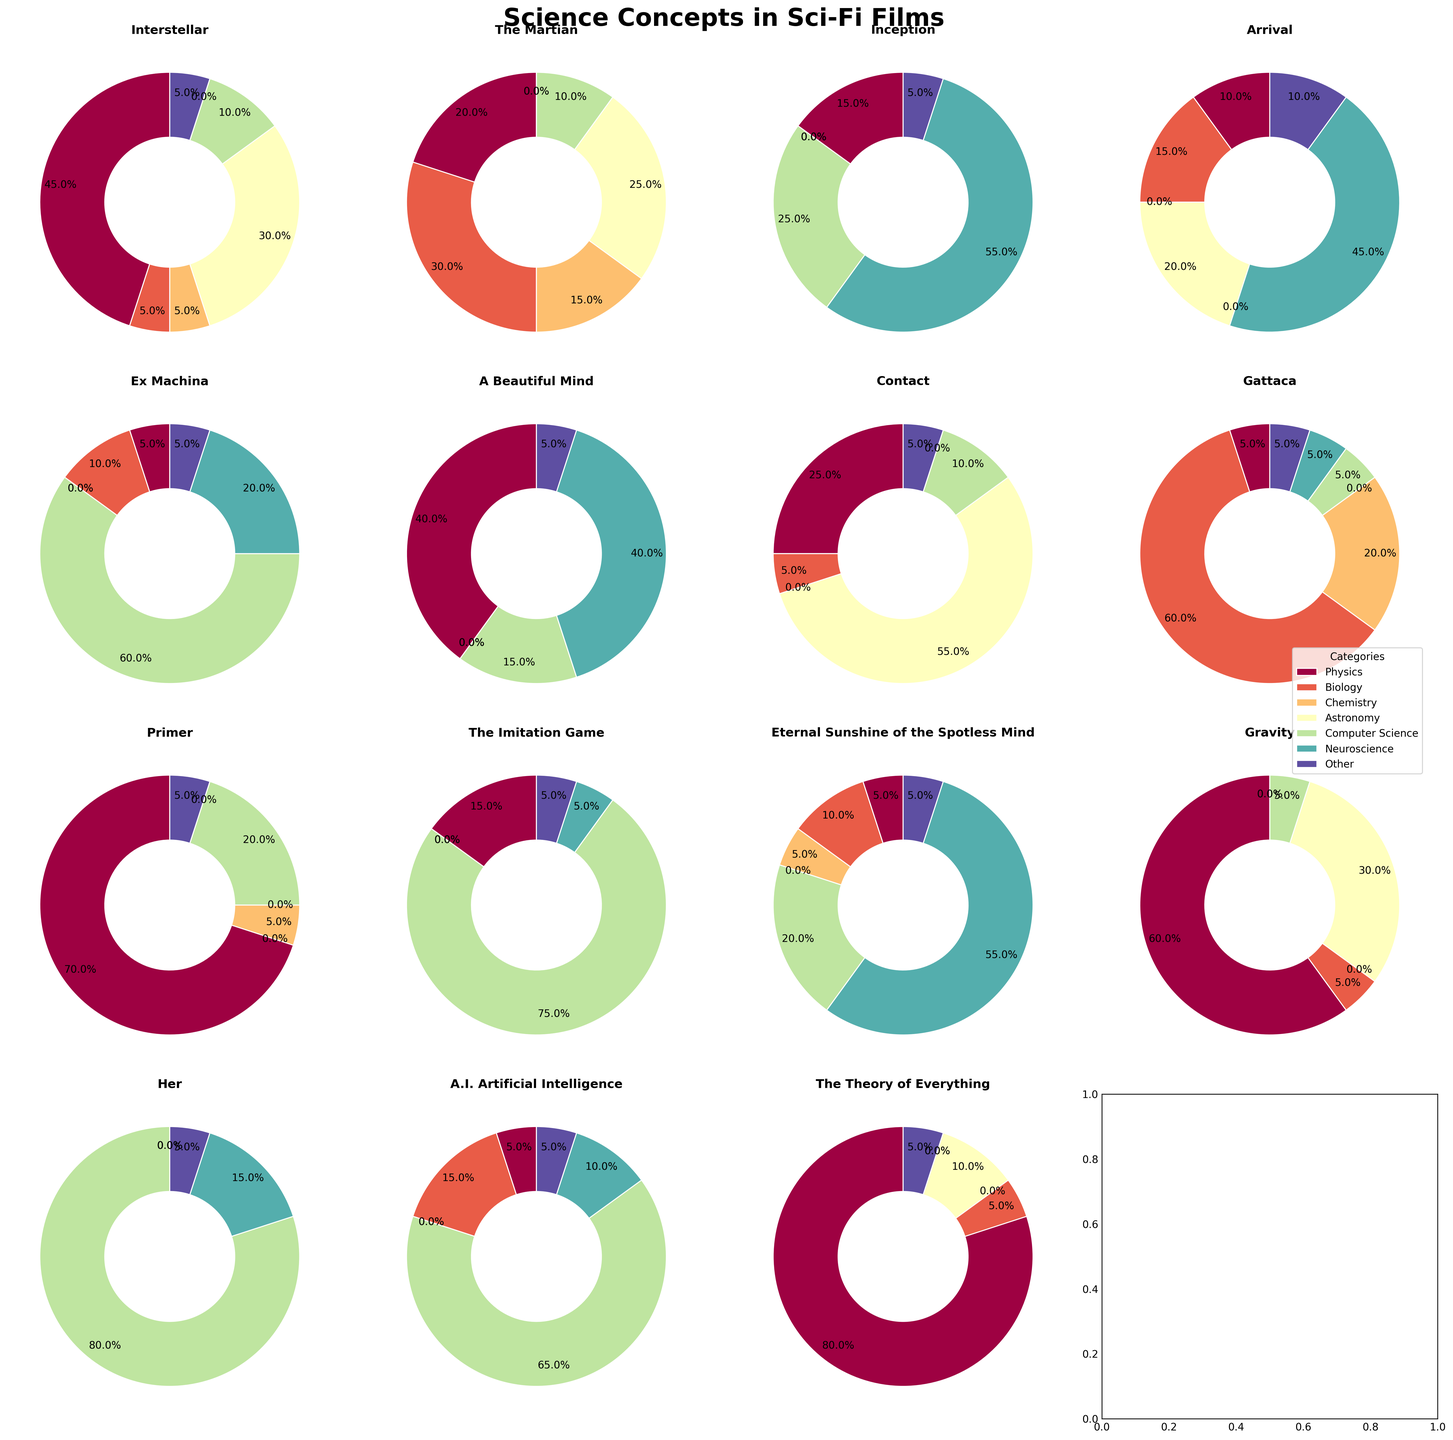What is the total screen time allocated to Computer Science across all films? Sum the percentages of Computer Science for each movie: 10 (Interstellar) + 10 (The Martian) + 25 (Inception) + 0 (Arrival) + 60 (Ex Machina) + 15 (A Beautiful Mind) + 10 (Contact) + 5 (Gattaca) + 20 (Primer) + 75 (The Imitation Game) + 20 (Eternal Sunshine) + 5 (Gravity) + 80 (Her) + 65 (A.I. Artificial Intelligence) + 0 (The Theory of Everything) = 400
Answer: 400 Which movie focuses the most on Neuroscience? Compare the sections of Neuroscience in all the pie charts. The movie with the largest Neuroscience section is Inception with 55%.
Answer: Inception Which movie has the least amount of screen time allocated to Physics? Compare the sections of Physics in each pie chart. The movies with the smallest Physics sections (5%) are Ex Machina, Gattaca, Her, and Eternal Sunshine of the Spotless Mind.
Answer: Ex Machina, Gattaca, Her, Eternal Sunshine of the Spotless Mind (all 5%) Which two scientific concepts have the greatest combined screen time in "The Martian"? Refer to "The Martian" pie chart. Biology has 30% and Astronomy has 25%. Their combined screen time is 30% + 25% = 55%.
Answer: Biology and Astronomy What is the difference in screen time allocated to Physics between "Gravity" and "The Theory of Everything"? Refer to both pie charts and compare. Screen time for Gravity is 60% and for The Theory of Everything is 80%. The difference is 80% - 60% = 20%.
Answer: 20% Which movie allocates a significant portion of its screen time to Astronomy, but none to Neuroscience? Compare pie charts for screen time for Astronomy and Neuroscience. Contact allocates 55% to Astronomy and 0% to Neuroscience.
Answer: Contact For "Gattaca," how much more screen time is allocated to Biology than to Astronomy? Refer to "Gattaca" pie chart. Biology is 60%, and Astronomy is 0%. The difference is 60% - 0% = 60%.
Answer: 60% What is the average screen time allocation for Chemistry across all films? Sum the percentages of Chemistry for each movie and divide by the number of films. Chemistry allocations are: 5 (Interstellar) + 15 (The Martian) + 0 (Inception) + 0 (Arrival) + 0 (Ex Machina) + 0 (A Beautiful Mind) + 0 (Contact) + 20 (Gattaca) + 5 (Primer) + 0 (The Imitation Game) + 5 (Eternal Sunshine) + 0 (Gravity) + 0 (Her) + 0 (A.I. Artificial Intelligence) + 0 (The Theory of Everything). Total is 50%. There are 15 films. Average = 50% / 15 = 3.33%.
Answer: 3.33% Which movie allocates an equal percentage of its screen time to both Physics and Chemistry? Compare the pie charts for equal sections of Physics and Chemistry. Interstellar allocates 45% to Physics and 5% to Chemistry; none have equal portions.
Answer: None 